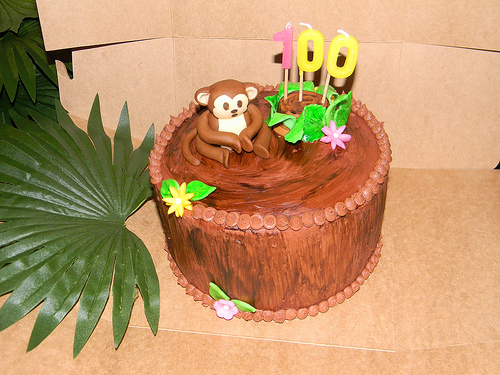<image>
Is the cake next to the leaf? Yes. The cake is positioned adjacent to the leaf, located nearby in the same general area. Where is the flower in relation to the monkey? Is it under the monkey? No. The flower is not positioned under the monkey. The vertical relationship between these objects is different. 